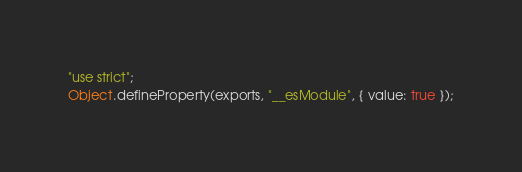<code> <loc_0><loc_0><loc_500><loc_500><_JavaScript_>"use strict";
Object.defineProperty(exports, "__esModule", { value: true });</code> 